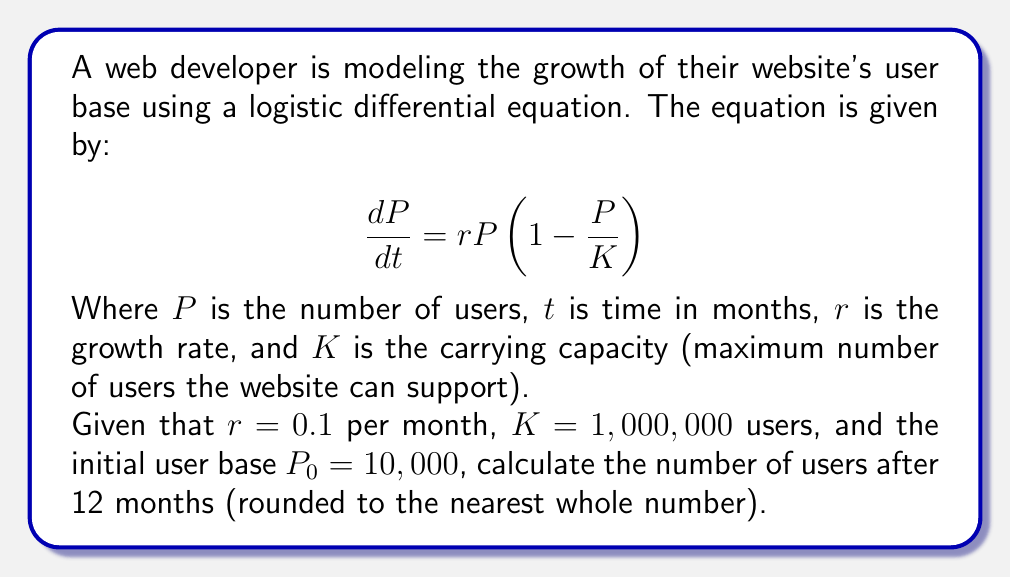Solve this math problem. Let's approach this step-by-step:

1) The logistic differential equation for population growth is:

   $$\frac{dP}{dt} = rP(1 - \frac{P}{K})$$

2) The solution to this equation is:

   $$P(t) = \frac{K}{1 + (\frac{K}{P_0} - 1)e^{-rt}}$$

3) We're given:
   - $r = 0.1$ per month
   - $K = 1,000,000$ users
   - $P_0 = 10,000$ users
   - $t = 12$ months

4) Let's substitute these values into the equation:

   $$P(12) = \frac{1,000,000}{1 + (\frac{1,000,000}{10,000} - 1)e^{-0.1 * 12}}$$

5) Simplify:
   
   $$P(12) = \frac{1,000,000}{1 + (99)e^{-1.2}}$$

6) Calculate $e^{-1.2}$:
   
   $$P(12) = \frac{1,000,000}{1 + 99 * 0.301194...}$$

7) Solve:
   
   $$P(12) = \frac{1,000,000}{30.818...} = 32,448.03...$$

8) Rounding to the nearest whole number:

   $$P(12) \approx 32,448$$
Answer: 32,448 users 